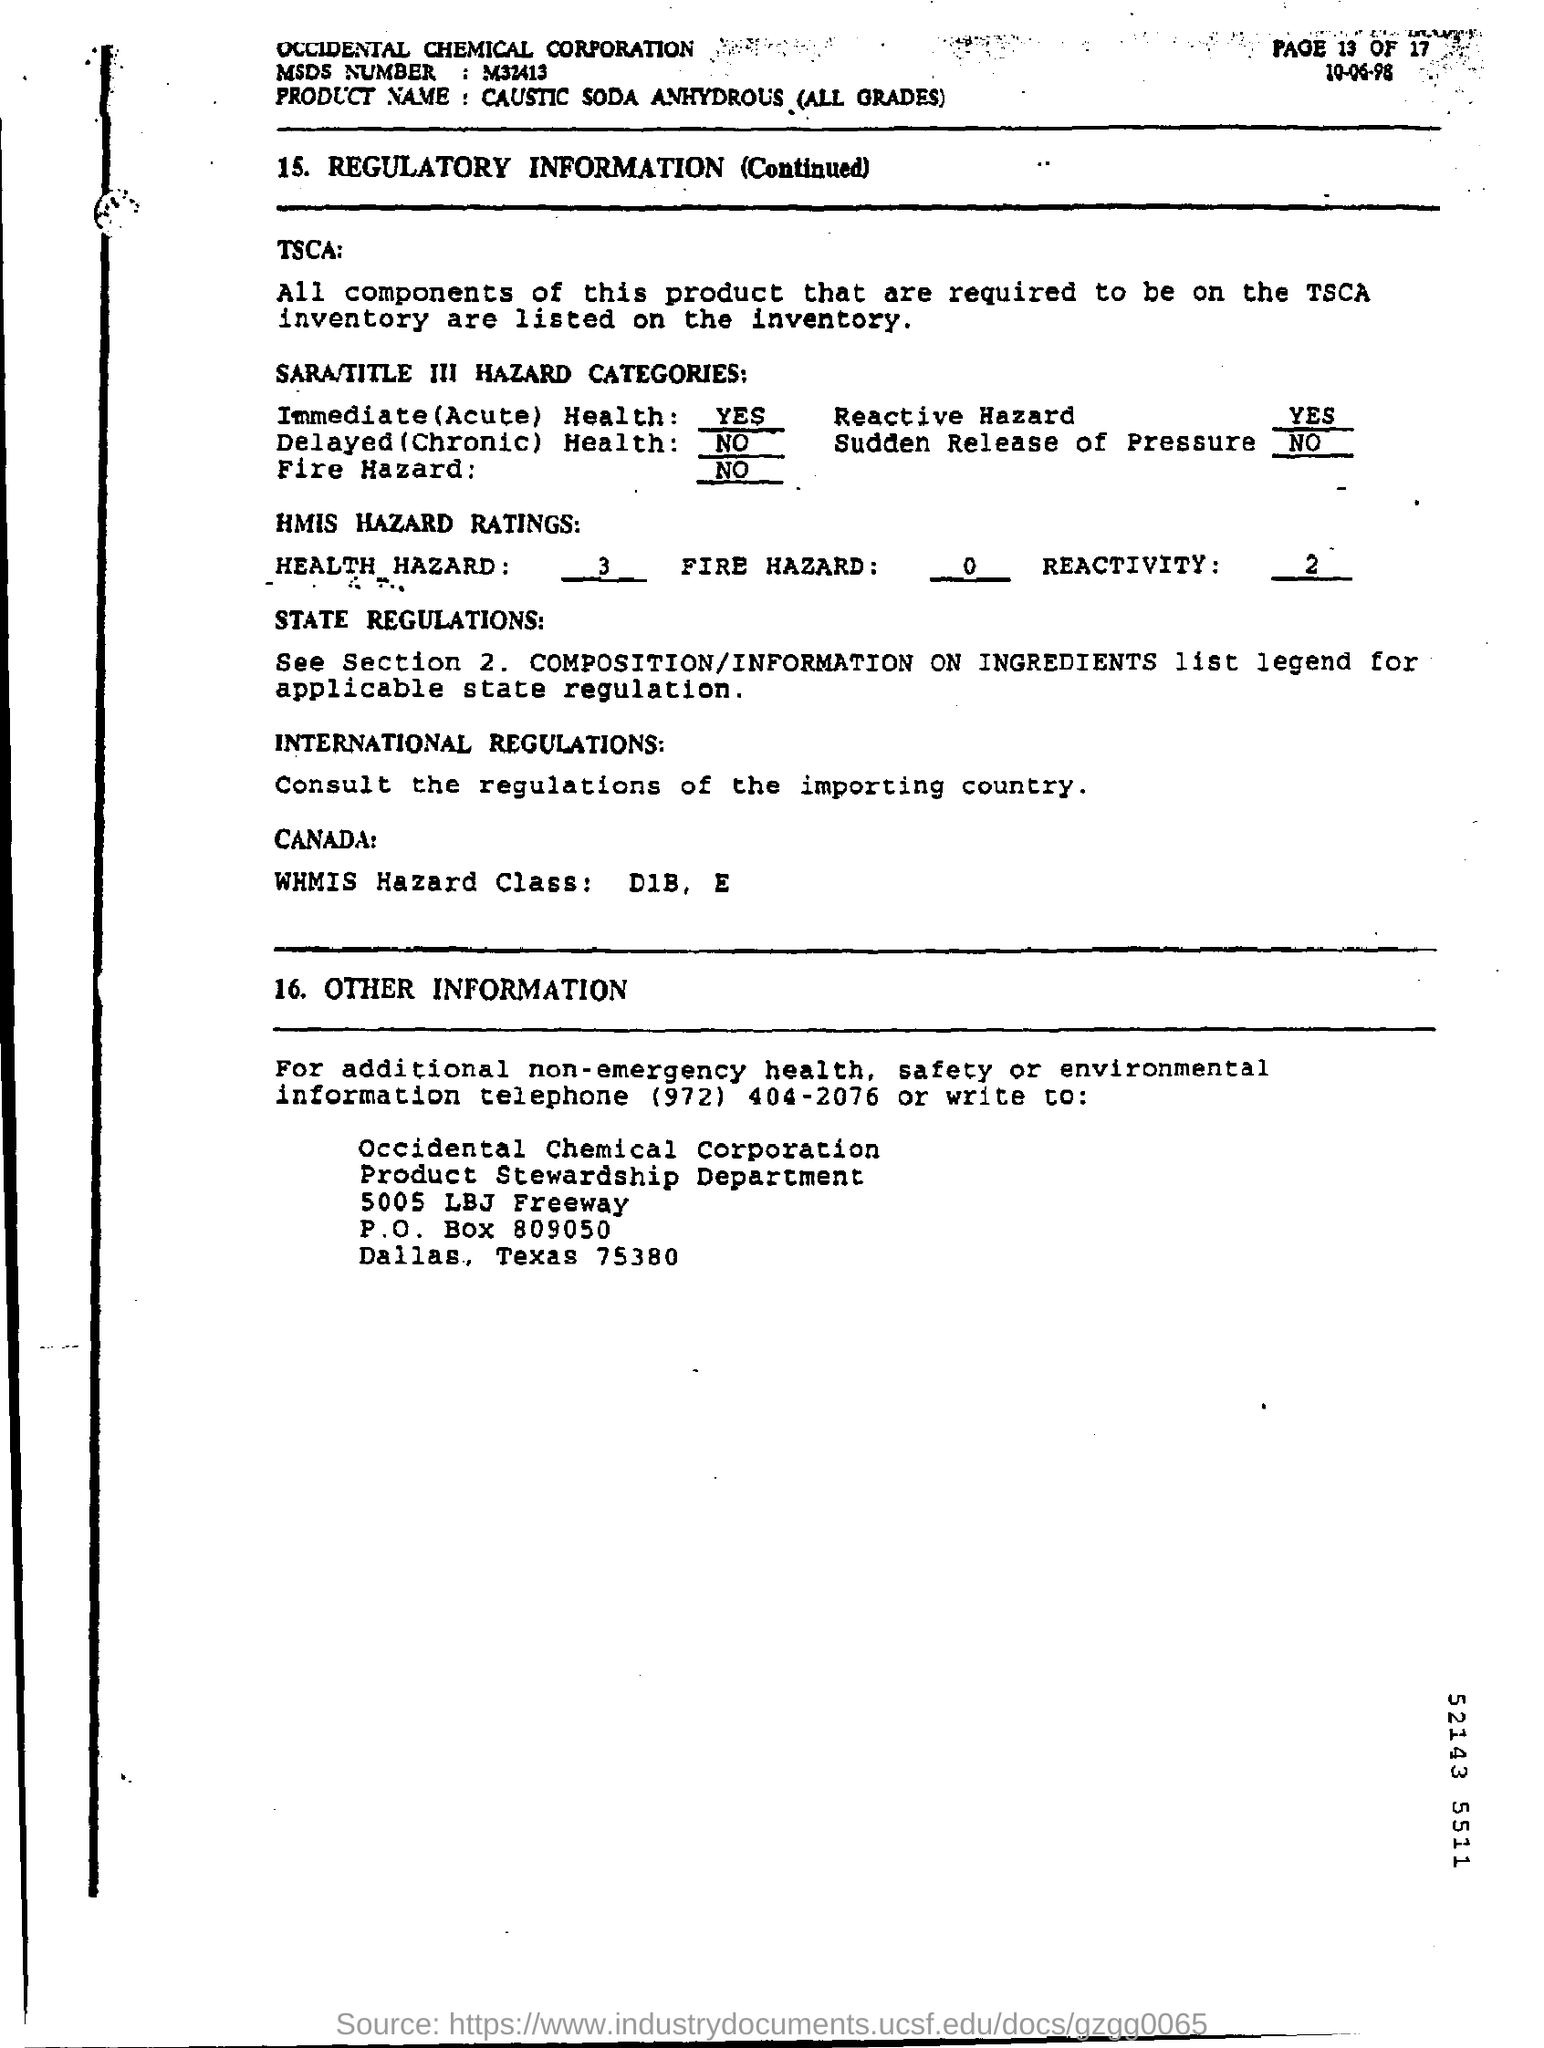Identify some key points in this picture. The immediate health field states 'YES.' Occidental Chemical Corporation is a company that specializes in the production and distribution of chemical products. The product name is Caustic Soda Anhydrous (all grades). The MSDS number, or Material Safety Data Sheet, is M32413. The WHMIS Hazard Class Field contains the designation "D1B, E. 